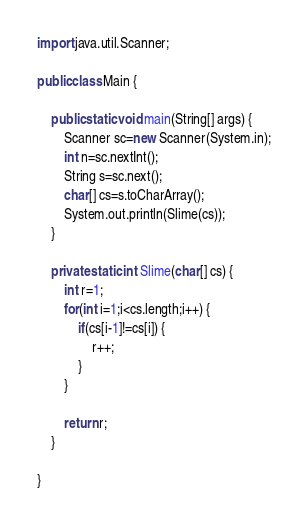<code> <loc_0><loc_0><loc_500><loc_500><_Java_>import java.util.Scanner;

public class Main {

	public static void main(String[] args) {
		Scanner sc=new Scanner(System.in);
		int n=sc.nextInt();
		String s=sc.next();
		char[] cs=s.toCharArray();
		System.out.println(Slime(cs));
	}

	private static int Slime(char[] cs) {
		int r=1;
		for(int i=1;i<cs.length;i++) {
			if(cs[i-1]!=cs[i]) {
				r++;
			}
		}

		return r;
	}

}
</code> 